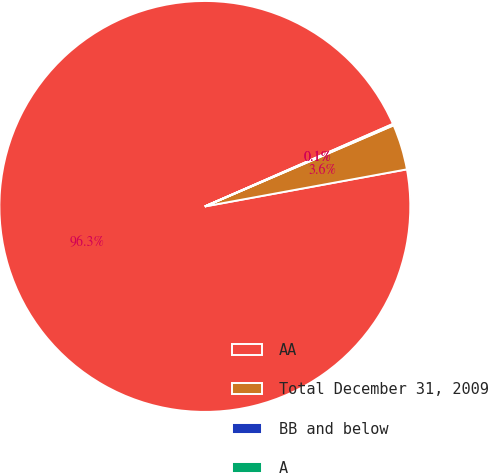Convert chart to OTSL. <chart><loc_0><loc_0><loc_500><loc_500><pie_chart><fcel>AA<fcel>Total December 31, 2009<fcel>BB and below<fcel>A<nl><fcel>96.31%<fcel>3.57%<fcel>0.06%<fcel>0.06%<nl></chart> 